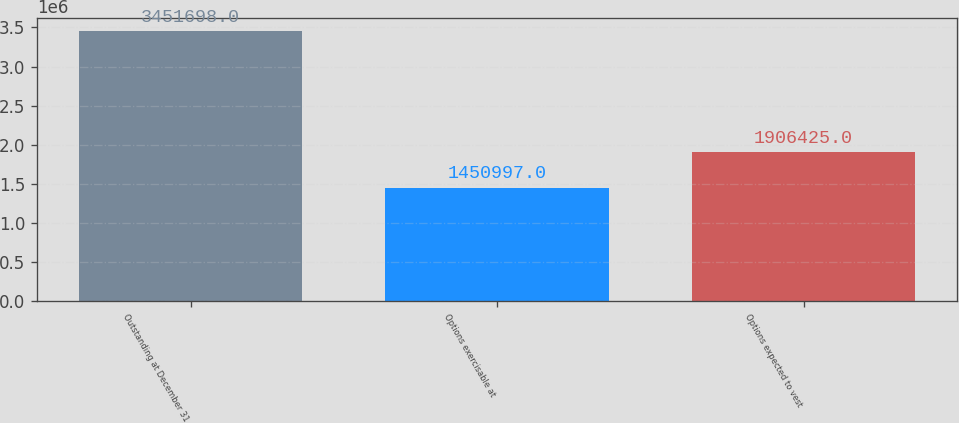Convert chart. <chart><loc_0><loc_0><loc_500><loc_500><bar_chart><fcel>Outstanding at December 31<fcel>Options exercisable at<fcel>Options expected to vest<nl><fcel>3.4517e+06<fcel>1.451e+06<fcel>1.90642e+06<nl></chart> 